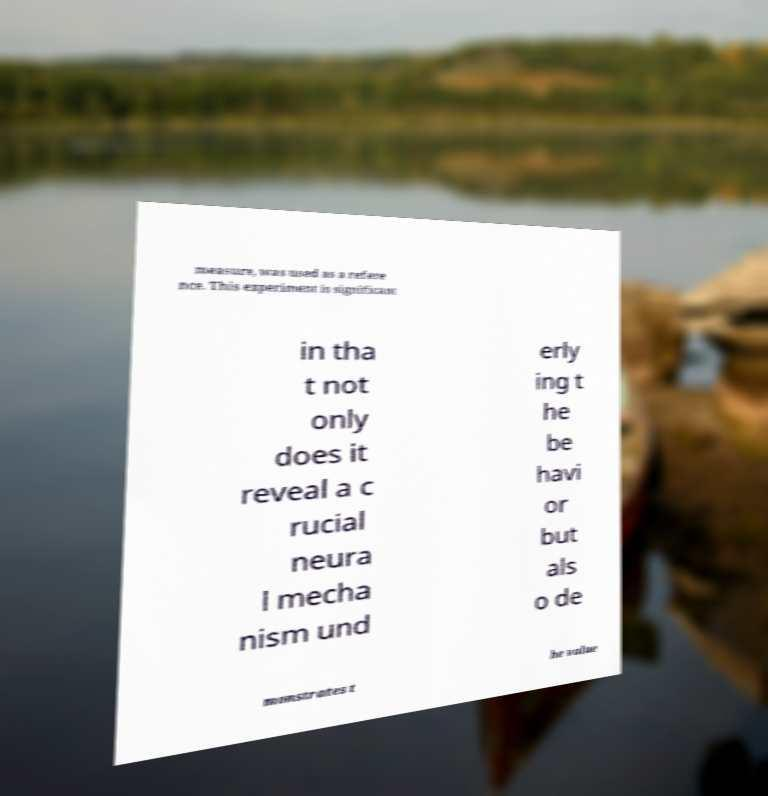Please identify and transcribe the text found in this image. measure, was used as a refere nce. This experiment is significant in tha t not only does it reveal a c rucial neura l mecha nism und erly ing t he be havi or but als o de monstrates t he value 